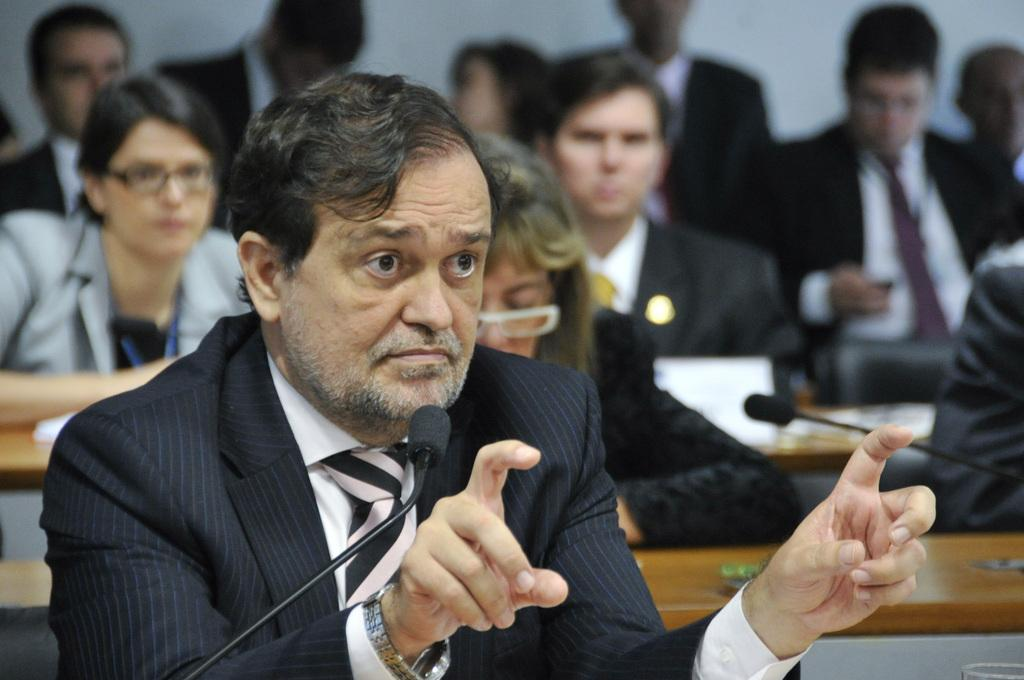How many people are in the image? There is a group of people in the image, but the exact number is not specified. What objects are present in the image that are used for amplifying sound? There are microphones (mics) in the image. What type of furniture can be seen in the image? There are tables in the image. What can be seen in the background of the image? There is a wall in the background of the image. Can you describe any other objects in the image besides the people, microphones, and tables? There are some unspecified objects in the image. What type of cart is being used to transport the people's minds in the image? There is no cart or mention of minds in the image; it features a group of people and microphones. 